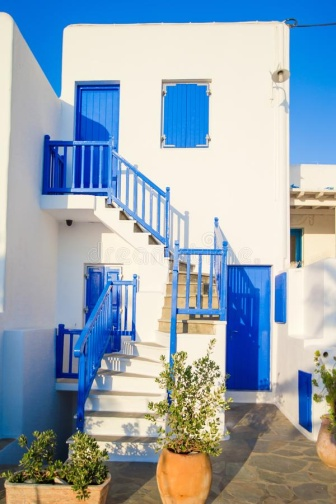Describe the following image. The image shows a charming, two-story Mediterranean-style house, painted in a crisp white with striking blue accents that convey a sense of coastal elegance. The first floor features a vibrant blue door central to the image, complemented by symmetrically placed windows, each adorned with blue shutters and white details enhancing their quaint appearance. A blue staircase on the right ascends gracefully to the second floor, leading to a welcoming balcony with a pristine white railing and a base of the same lively blue as seen elsewhere. This balcony offers a hint of a peaceful retreat, overlooking the front of the property. Adorning the entrance, three terracotta pots house flourishing green plants, including two lush olive trees, which introduce an element of natural beauty and contrast vividly with the building's color scheme. The backdrop of a clear blue sky completes the ideal Mediterranean setting, emphasizing the brightness and warmth of the scene. 